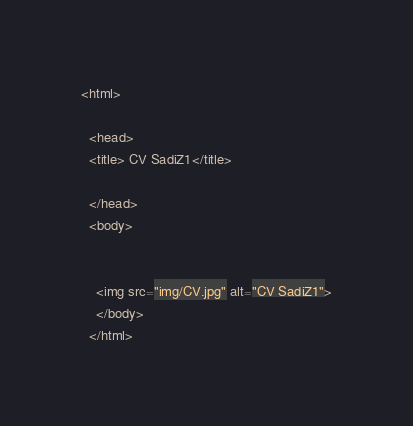Convert code to text. <code><loc_0><loc_0><loc_500><loc_500><_HTML_><html>
  
  <head>
  <title> CV SadiZ1</title>
  
  </head>
  <body>
    
    
    <img src="img/CV.jpg" alt="CV SadiZ1">
    </body>
  </html>
</code> 